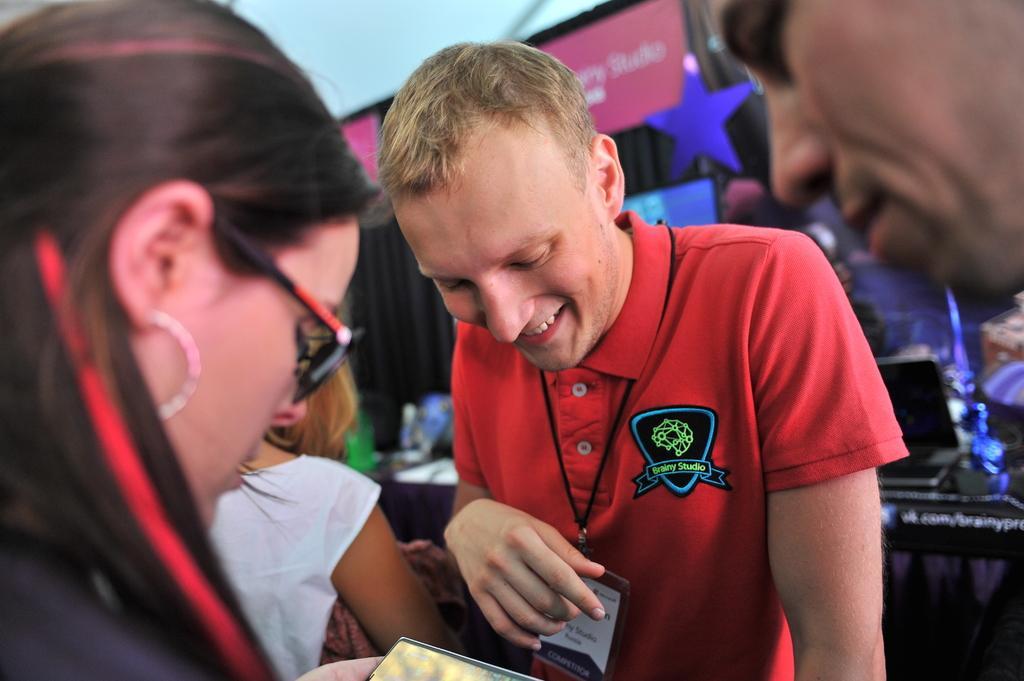Describe this image in one or two sentences. There are two women towards the bottom of the image, the woman is holding an object, there is a man towards the bottom of the image, he is wearing an identity card, there is a man's face towards the right of the image, there is a table behind the persons, there is a cloth on the table, there are objects on the table, there is a star, there is a board, there is text on the board, there is a curtain, there is a roof towards the top of the image. 